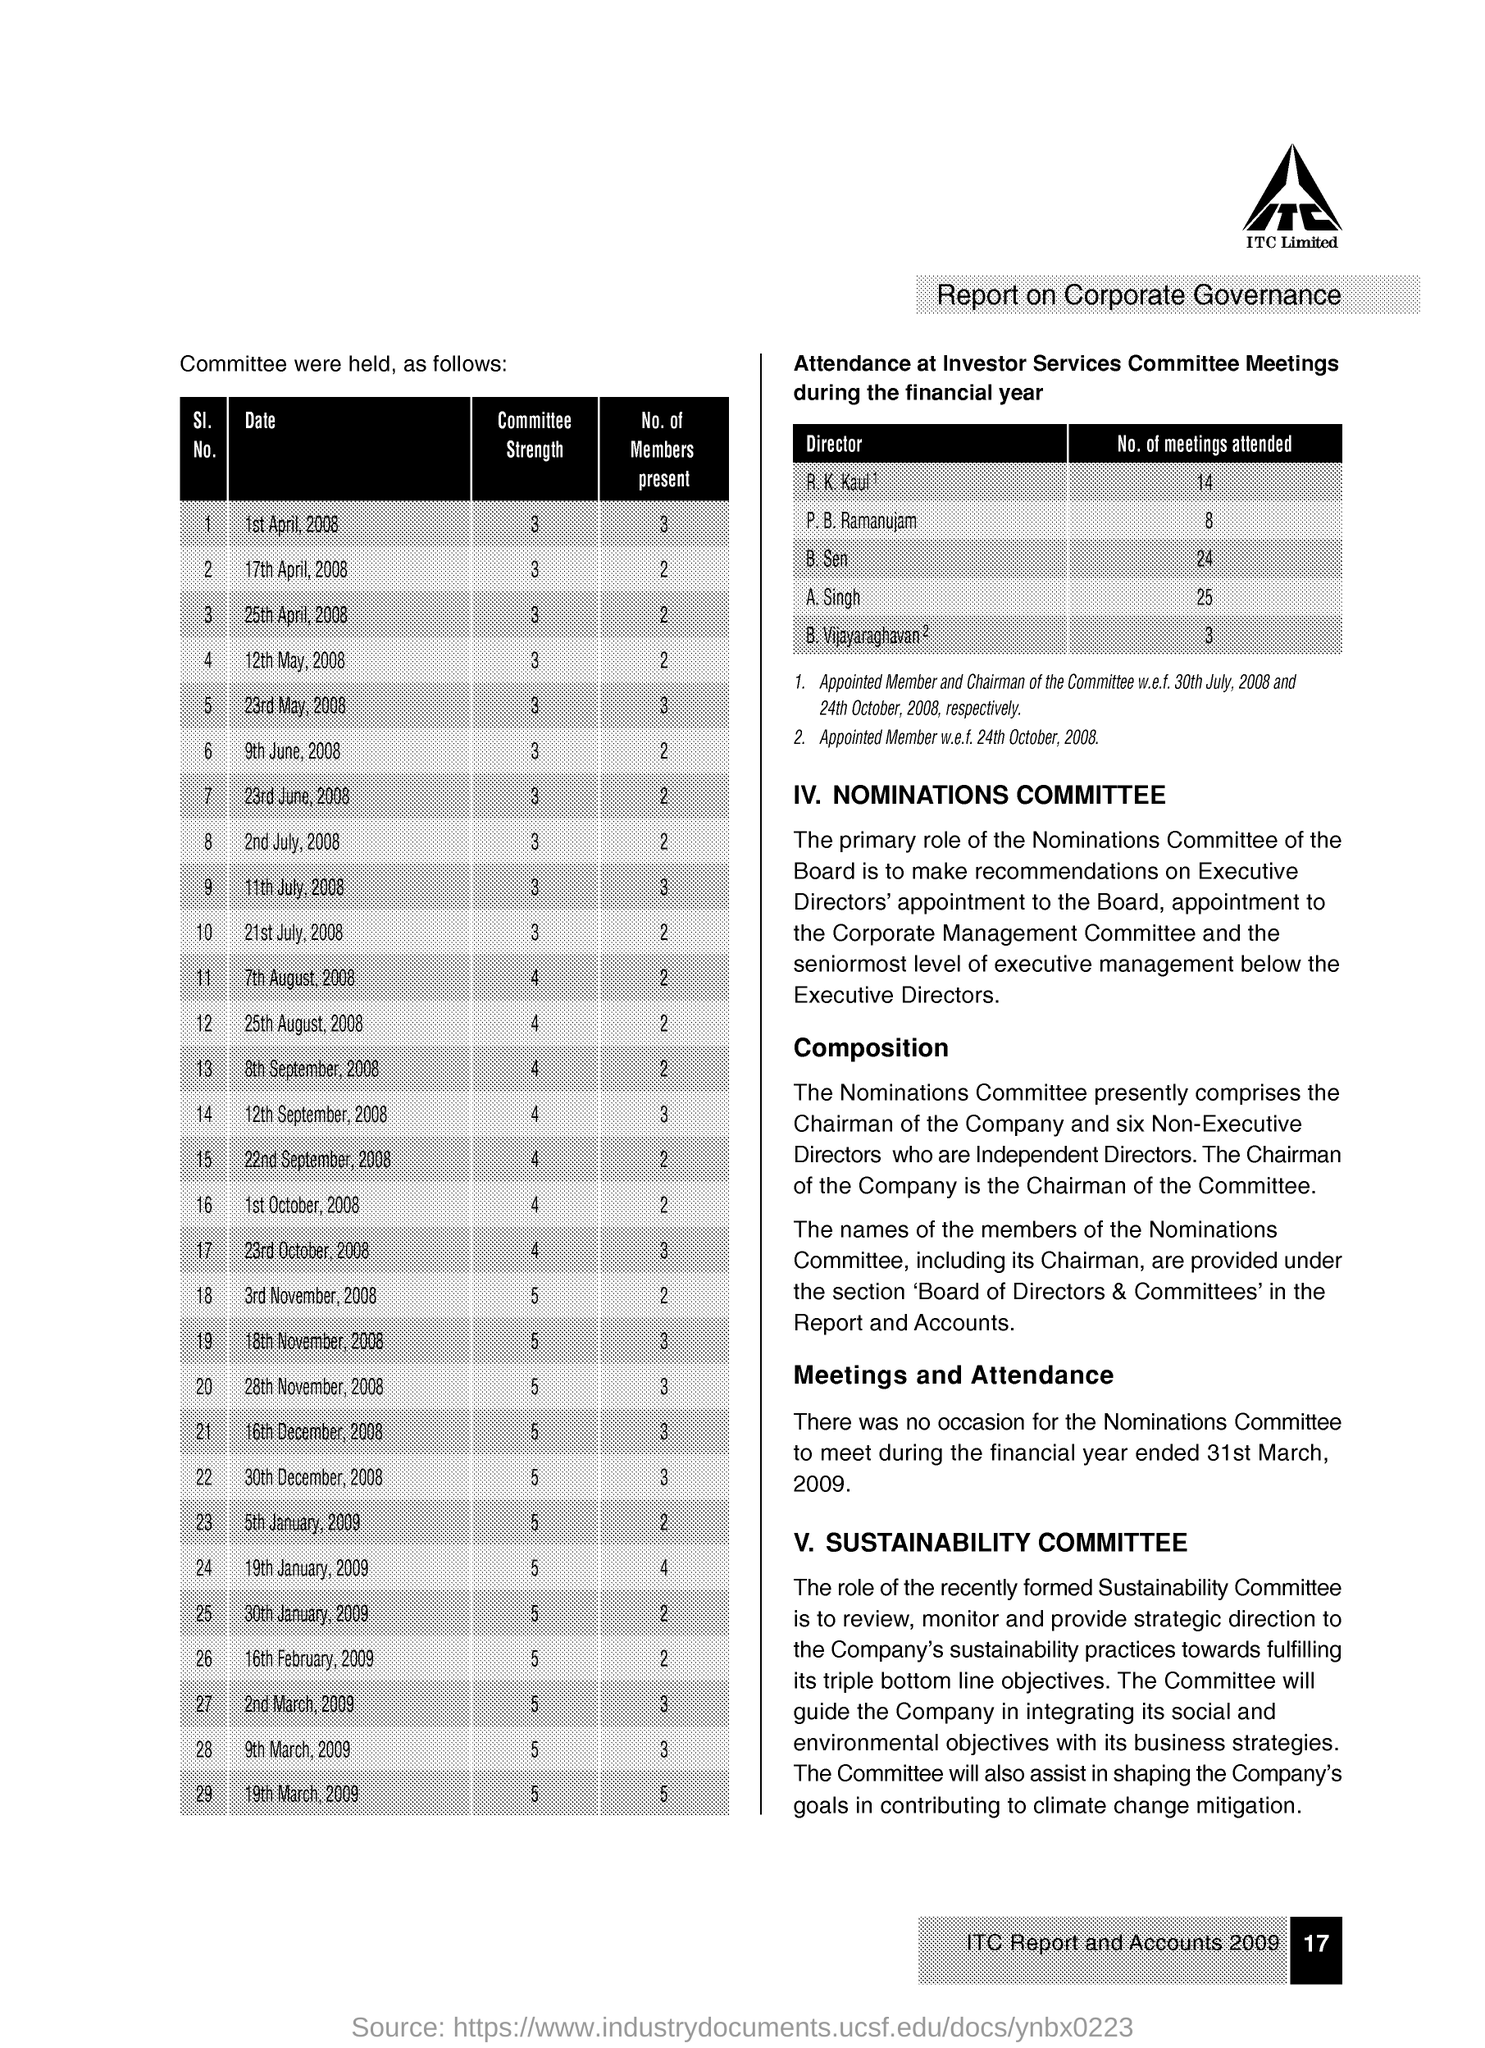How many meetings attended the B. Sen
Your answer should be compact. 24. 